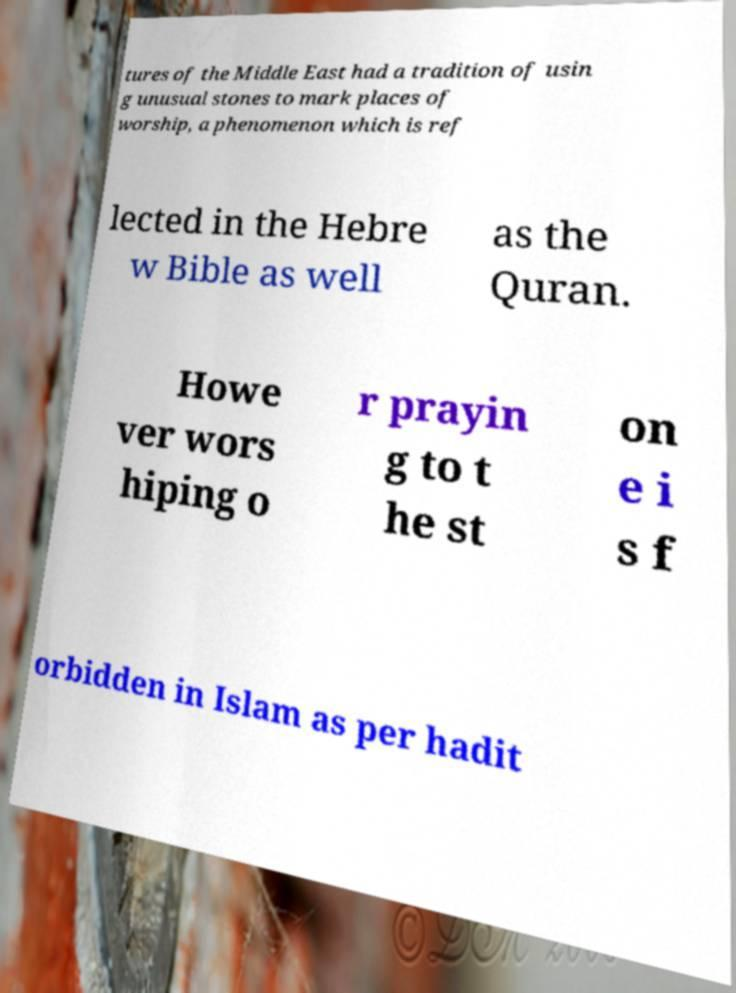Please identify and transcribe the text found in this image. tures of the Middle East had a tradition of usin g unusual stones to mark places of worship, a phenomenon which is ref lected in the Hebre w Bible as well as the Quran. Howe ver wors hiping o r prayin g to t he st on e i s f orbidden in Islam as per hadit 